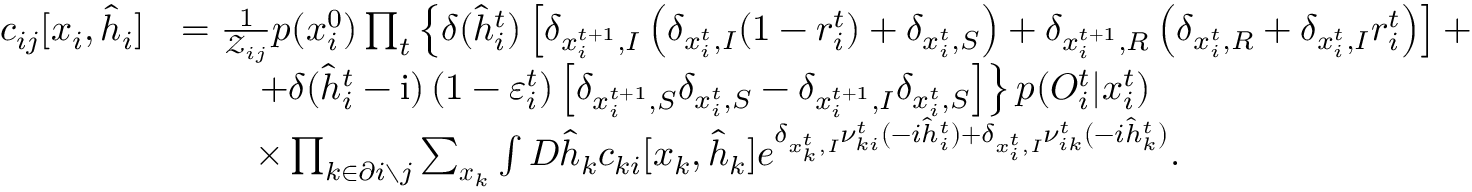Convert formula to latex. <formula><loc_0><loc_0><loc_500><loc_500>\begin{array} { r l } { c _ { i j } [ x _ { i } , \hat { h } _ { i } ] } & { = \frac { 1 } { \mathcal { Z } _ { i j } } p ( x _ { i } ^ { 0 } ) \prod _ { t } \left \{ \delta ( \hat { h } _ { i } ^ { t } ) \left [ \delta _ { x _ { i } ^ { t + 1 } , I } \left ( \delta _ { x _ { i } ^ { t } , I } ( 1 - r _ { i } ^ { t } ) + \delta _ { x _ { i } ^ { t } , S } \right ) + \delta _ { x _ { i } ^ { t + 1 } , R } \left ( \delta _ { x _ { i } ^ { t } , R } + \delta _ { x _ { i } ^ { t } , I } r _ { i } ^ { t } \right ) \right ] + } \\ & { \quad + \delta ( \hat { h } _ { i } ^ { t } - i ) \left ( 1 - \varepsilon _ { i } ^ { t } \right ) \left [ \delta _ { x _ { i } ^ { t + 1 } , S } \delta _ { x _ { i } ^ { t } , S } - \delta _ { x _ { i } ^ { t + 1 } , I } \delta _ { x _ { i } ^ { t } , S } \right ] \right \} p ( { O } _ { i } ^ { t } | x _ { i } ^ { t } ) } \\ & { \quad \times \prod _ { k \in \partial i \ j } \sum _ { x _ { k } } \int D \hat { h } _ { k } c _ { k i } [ x _ { k } , \hat { h } _ { k } ] e ^ { \delta _ { x _ { k } ^ { t } , I } \nu _ { k i } ^ { t } ( - i \hat { h } _ { i } ^ { t } ) + \delta _ { x _ { i } ^ { t } , I } \nu _ { i k } ^ { t } ( - i \hat { h } _ { k } ^ { t } ) } . } \end{array}</formula> 